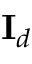<formula> <loc_0><loc_0><loc_500><loc_500>I _ { d }</formula> 